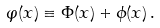<formula> <loc_0><loc_0><loc_500><loc_500>\varphi ( x ) \equiv \Phi ( x ) + \phi ( x ) \, .</formula> 